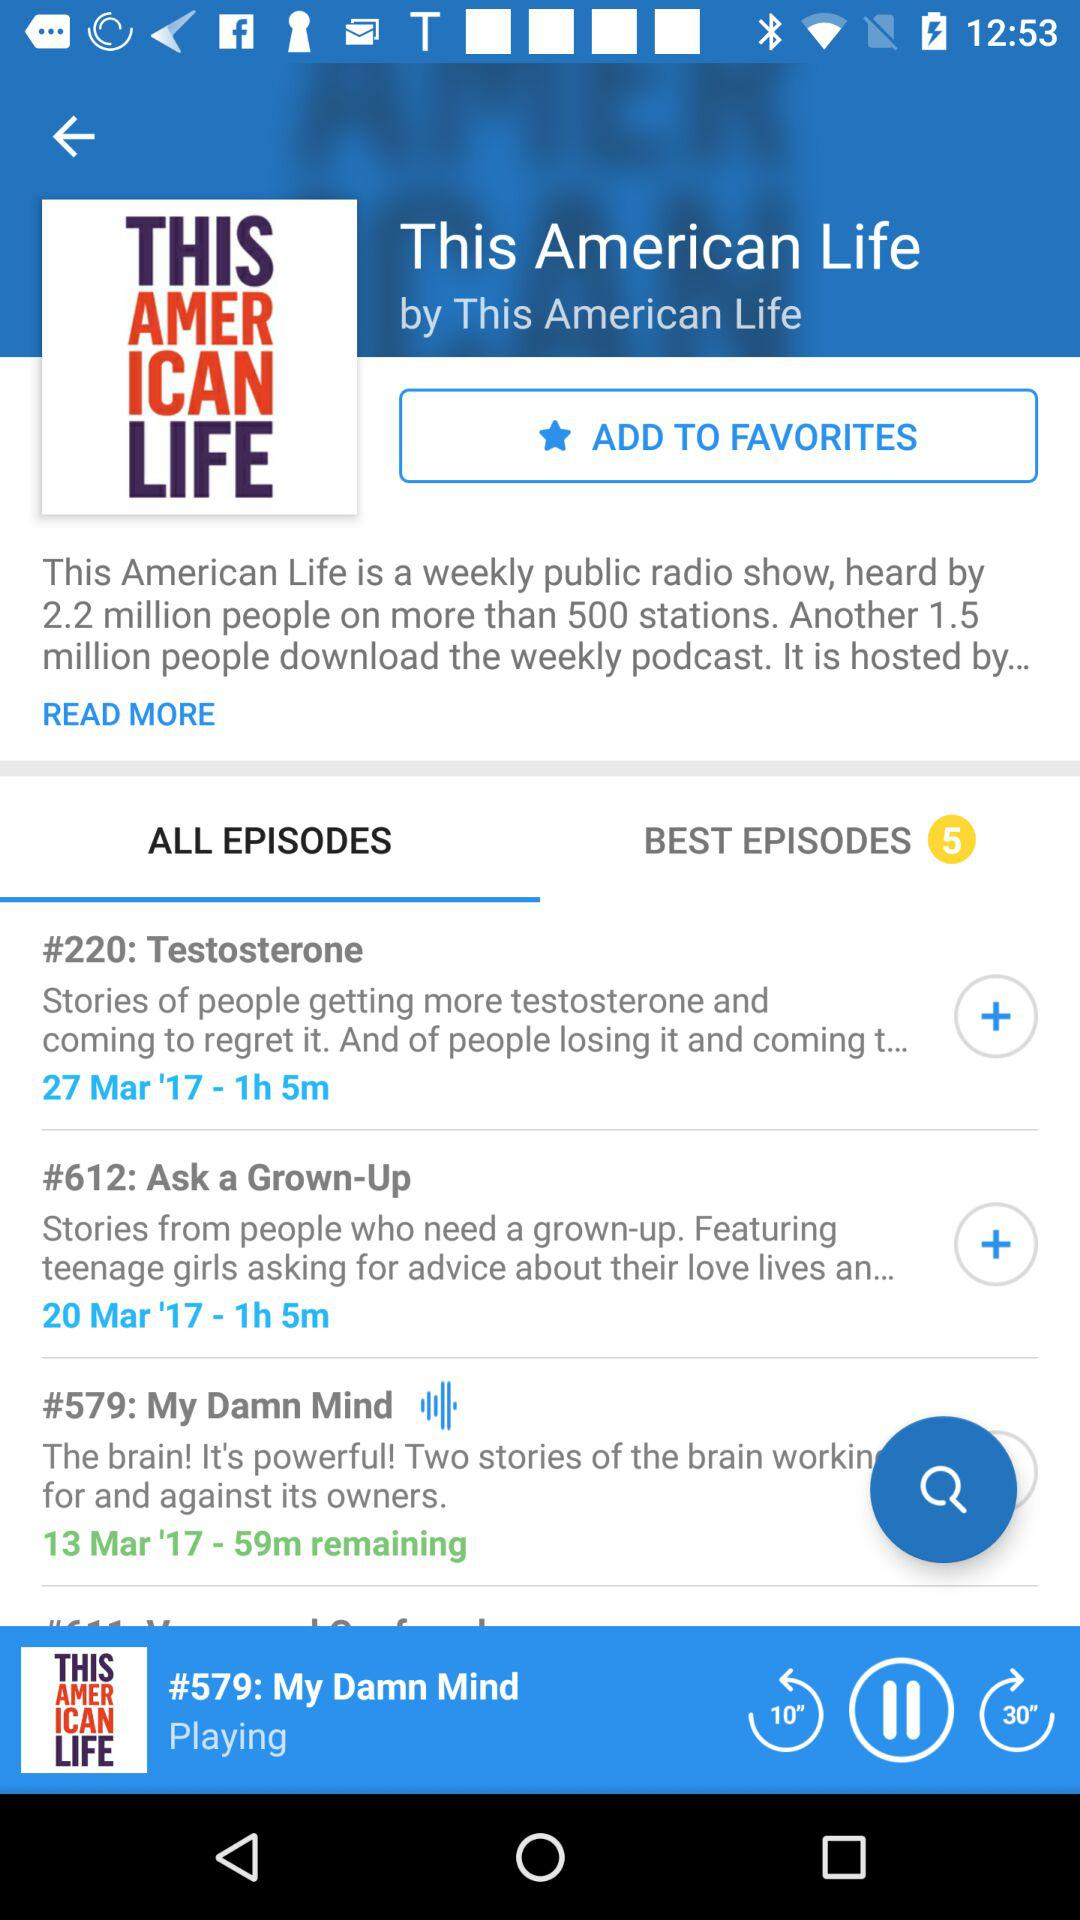How many people have heard "This American life"? "This American life" has been heard by 2.2 million people. 